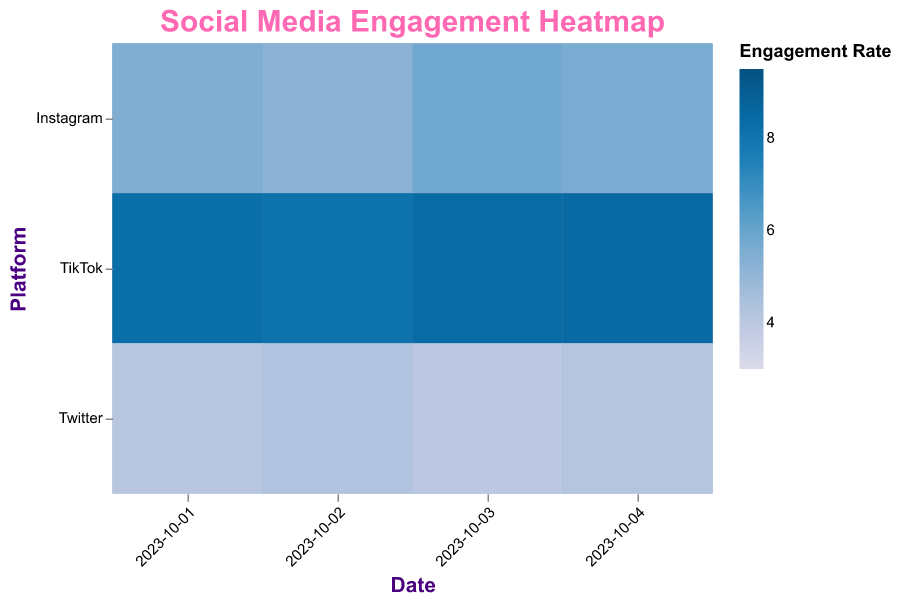What is the title of the heatmap? The title of the heatmap is usually displayed at the top of the figure. For this heatmap, it is "Social Media Engagement Heatmap".
Answer: Social Media Engagement Heatmap Which social media platform has the highest engagement rate for videos on October 3rd? Locate October 3rd on the x-axis and then look at the entries in the heatmap related to videos. Compare the colors to find the platform with the darkest color, which indicates the highest engagement rate. Based on the data, TikTok has the highest engagement rate for videos on October 3rd.
Answer: TikTok On which date did Twitter have the highest engagement rate for images? Check the entries in the heatmap for Twitter's image engagement rates across all dates. The darkest color box represents the highest engagement rate. The highest engagement rate for images on Twitter is on October 4th.
Answer: October 4th Which type of social media post had the highest average engagement rate on Instagram over the four days? To find the average engagement rate, sum the engagement rates for each type of post (images, videos, stories) on Instagram across the four days and calculate the average value. The computations are:
- Images: (4.3 + 4.7 + 3.9 + 4.0) / 4 = 4.225
- Videos: (6.1 + 6.4 + 6.0 + 6.2) / 4 = 6.175
- Stories: (5.5 + 5.2 + 5.8 + 5.6) / 4 = 5.525
Videos have the highest average engagement rate.
Answer: Videos Which platform had the lowest engagement rate for any type of post on October 1st? Compare all engagement rates across all platforms for October 1st. Twitter's image post has the lowest engagement rate with 3.0.
Answer: Twitter What was the engagement rate for TikTok stories on October 2nd? Locate October 2nd along the x-axis, then find the intersection with the row labeled TikTok and the column related to stories. The engagement rate provided is 8.1.
Answer: 8.1 Compare the engagement rates of Instagram videos and Twitter videos on October 4th. Which one is higher? Locate October 4th along the x-axis and compare the engagement rates for videos on Instagram and Twitter. Instagram's engagement rate is 6.2, while Twitter's is 5.1. Instagram's rate is higher.
Answer: Instagram What's the average engagement rate for images across all platforms on October 3rd? Sum the engagement rates for image posts across all platforms on October 3rd and divide by the number of platforms. 
- Instagram: 3.9
- TikTok: 5.6
- Twitter: 3.1
Average: (3.9 + 5.6 + 3.1) / 3 = 4.2
Answer: 4.2 Which type of post has the most consistent engagement rates on TikTok over the four days? Consistency can be analyzed by observing the engagement rates and noting the smallest range or variation. TikTok's engagement rates for videos are 9.1, 9.5, 9.3, and 9.4, showing only slight variation.
Answer: Videos 